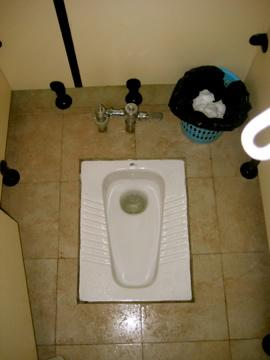Describe the condition of the bathroom in the image, including any stains or dirt. The bathroom has stains on the ground, dirt on the crease of the urinal, dirty toilet paper in the garbage bag, and some objects appear to be dusty or dirty. What is unique about the urinal in the image, and provide its dimensions? The urinal is oval-shaped and basal with dimensions Width:121 Height:121. Identify the main objects in the image and their color. The main objects are a blue basket, a clean toilet, a black garbage bag with white trash, and brown tile on the floor. List three additional objects found in the image that are not directly related to the bathroom. A lamp on the roof, reflections from the camera, and a white tube next to the wall. Briefly describe the wall and floor appearance in this image. The wall is cream-colored, and the floor has brown tiles with grey grout lines. In a few words, what does the image showcase? A bathroom scene with a toilet, wastebasket, and trash. Mention the objects found in the image that are related to cleaning or maintaining cleanliness. A clean toilet, the blue wastebasket, a garbage disposal bin, and a black bag lining the trash can. What are the features of the toilet in the image? The toilet is clean, square-shaped, has silver plumbing with a handle, a drain, and grooves in the porcelain. Count the number of times "white trash in a black bag" appears with different image coordinates. There are 10 instances of white trash in a black bag with different image coordinates. Which object in the image has the largest size and provide its dimensions? The largest object is the toilet with dimensions Width:150 Height:150. Does the image have a cream colored wall or green wall? Cream colored wall Describe the flooring, trash can contents, and plumbing in the image. The flooring has brown tiles, the trash can contains dirty toilet paper, and there is silver plumbing with a handle. Compose a short written piece that includes a blue basket and a clean toilet. In a quaint, neat bathroom, a sparkling clean toilet rests gracefully next to a captivating blue basket filled with freshly folded towels. What action is a person performing in the image? No person is present in the image. Describe the appearance of the squat-style toilet in the image with an artistic touch. A sleek and pristine squat-style toilet, a testament to modern design, elegantly sits amidst the intimate confines of the washroom. Detail the appearance of the trash can lining, a tube, and the toilet drain. The trash can has a black bag lining, there is a white tube next to the wall, and the toilet drain is at the bottom of the toilet bowl. Is there any significant event happening in the image? No significant event is detected. What is the current state of the garbage disposal bin? Empty, no garbage Explain the arrangement of the objects in the bathroom. A clean square toilet sits near a blue wastebasket, with a black bag lining a trash can nearby. Silver plumbing with a handle is also visible. Identify any text that appears in the image. No text is present in the image. Provide a creative description for a wastebasket in the image. A vibrant blue wastebasket sits unassumingly in the corner of the bathroom, awaiting discarded items. What color is the basket? Blue What item appears in the black trash bag? Dirty toilet paper Identify any numbers visible in the image. No numbers are visible in the image. Is there a party happening in the image? No, there is no party happening. Write a poem about a clean toilet in the bathroom. In porcelain gleam and spotless fare, Describe the layout of the tiles in the restroom. The tiles are arranged in a grid pattern, with grey grout lines separating them. Is the toilet clean or dirty? Clean 